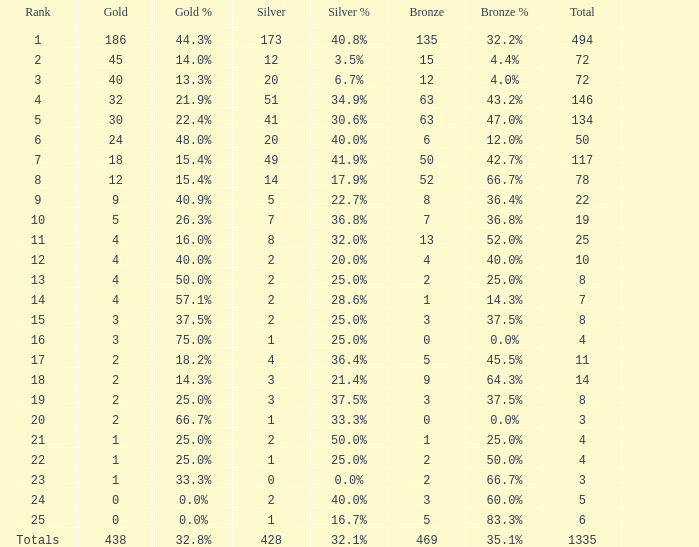What is the total amount of gold medals when there were more than 20 silvers and there were 135 bronze medals? 1.0. 